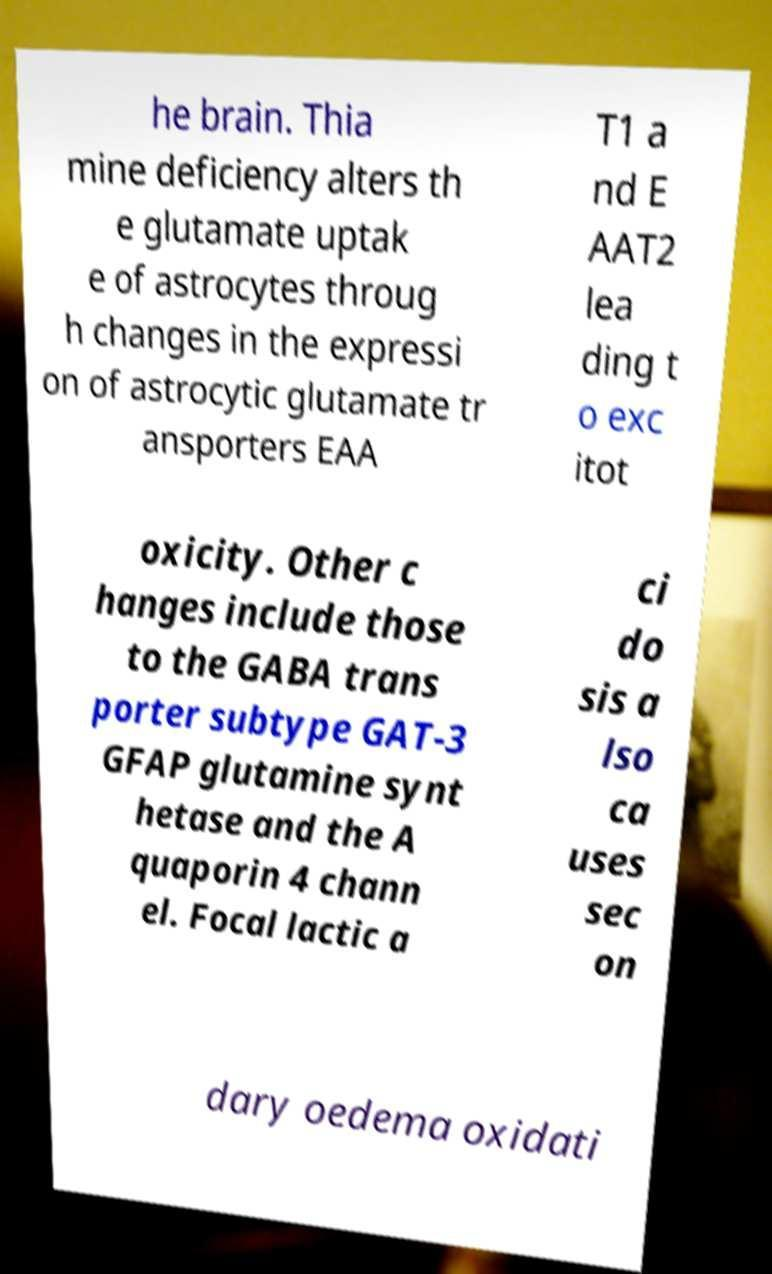For documentation purposes, I need the text within this image transcribed. Could you provide that? he brain. Thia mine deficiency alters th e glutamate uptak e of astrocytes throug h changes in the expressi on of astrocytic glutamate tr ansporters EAA T1 a nd E AAT2 lea ding t o exc itot oxicity. Other c hanges include those to the GABA trans porter subtype GAT-3 GFAP glutamine synt hetase and the A quaporin 4 chann el. Focal lactic a ci do sis a lso ca uses sec on dary oedema oxidati 